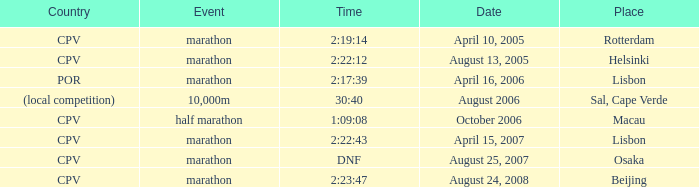What is the location of the event on august 25, 2007? Osaka. 